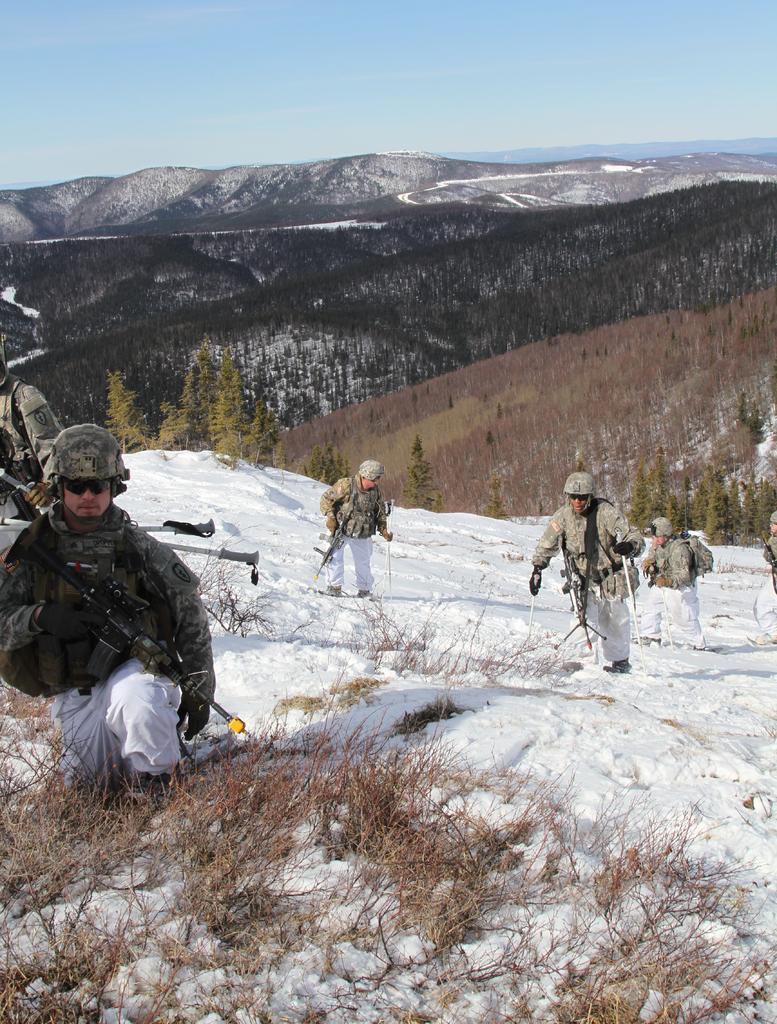Could you give a brief overview of what you see in this image? In this image I can see some people. I can see the snow. In the background, I can see the trees, hills and the sky. 